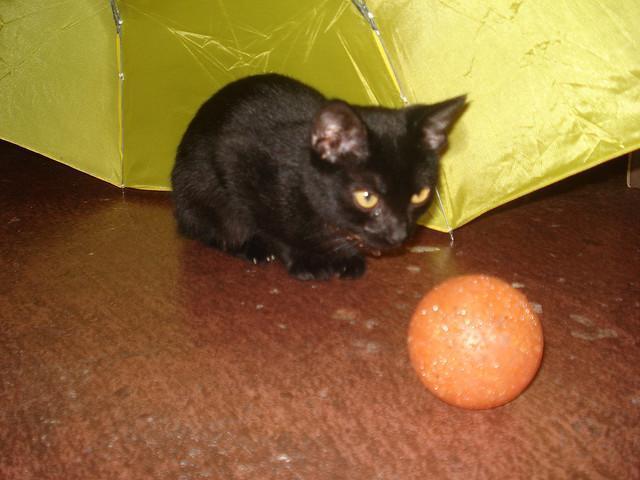How many people are wearing green shirts?
Give a very brief answer. 0. 